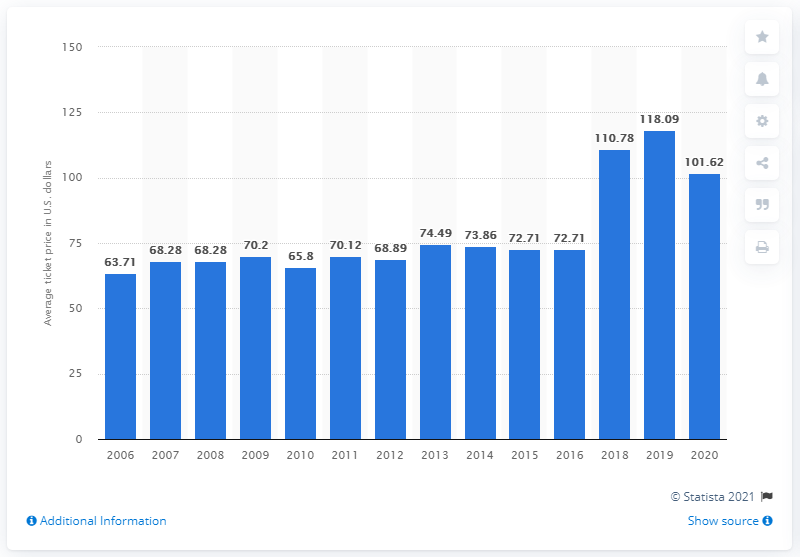Point out several critical features in this image. The average ticket price for Los Angeles (St. Louis) Rams games began in 2006. The average ticket price for Los Angeles (St. Louis) Rams games in 2020 was $101.62. 